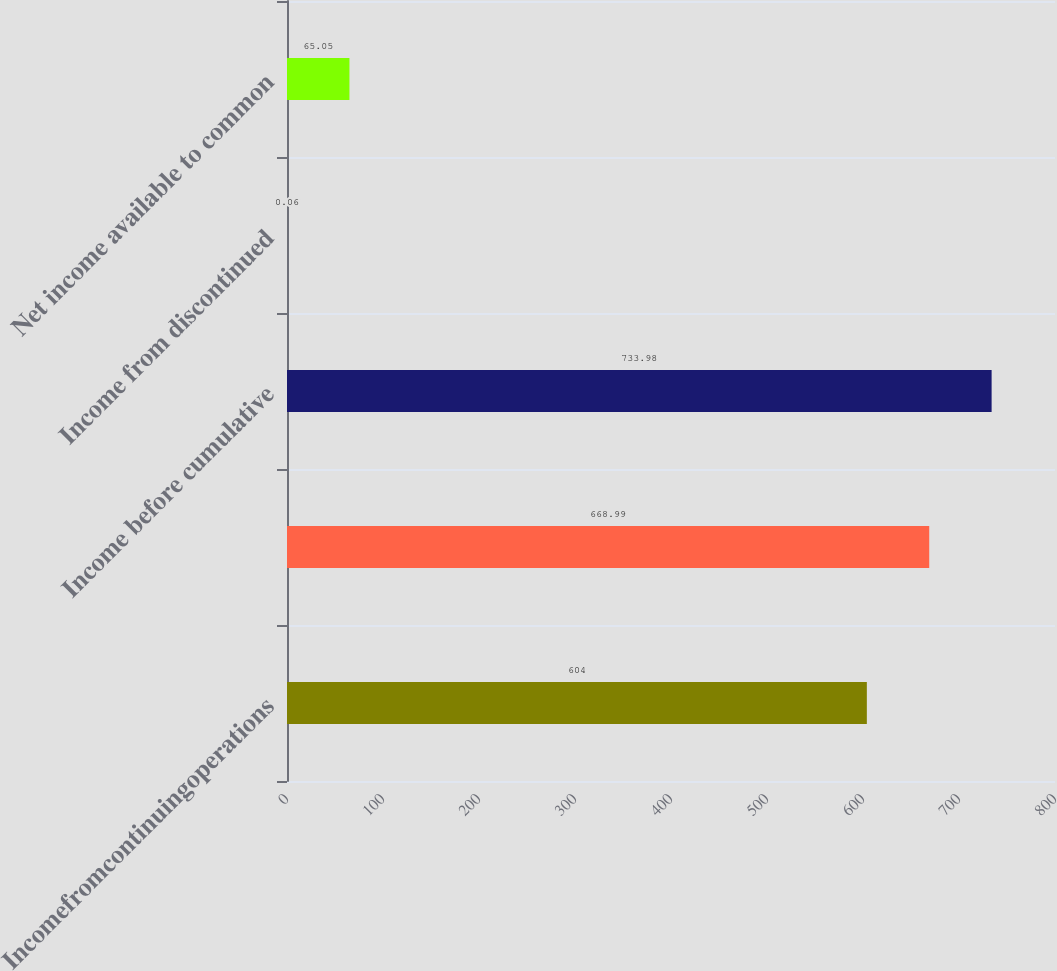Convert chart to OTSL. <chart><loc_0><loc_0><loc_500><loc_500><bar_chart><fcel>Incomefromcontinuingoperations<fcel>Unnamed: 1<fcel>Income before cumulative<fcel>Income from discontinued<fcel>Net income available to common<nl><fcel>604<fcel>668.99<fcel>733.98<fcel>0.06<fcel>65.05<nl></chart> 